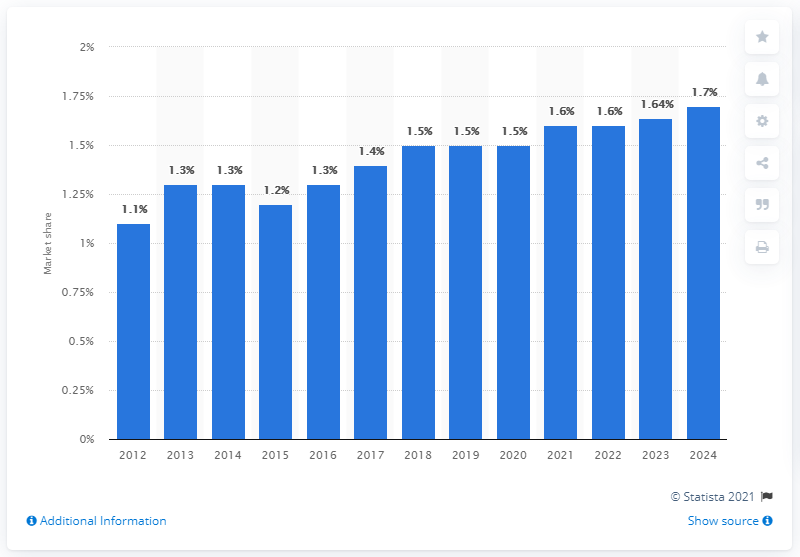Indicate a few pertinent items in this graphic. In 2018, Este Lauder's share of the global hair care products market was 1.5%. 